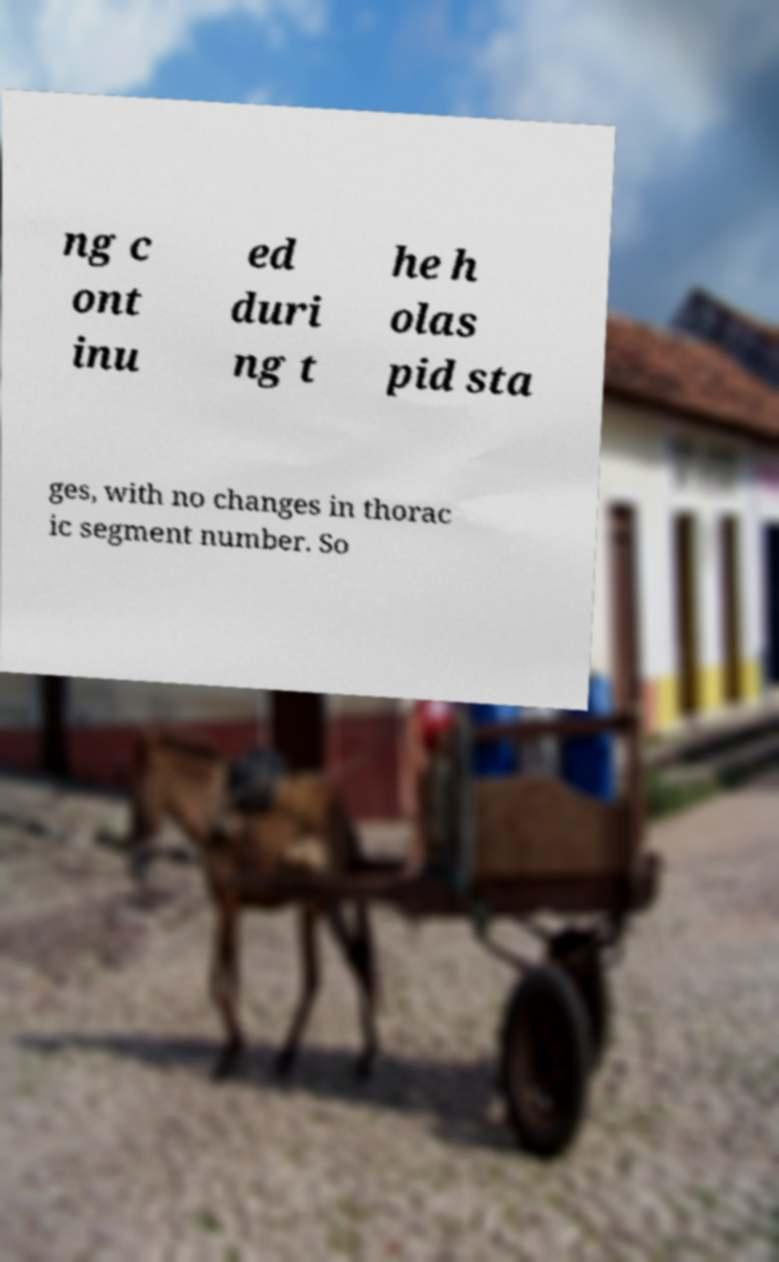Please identify and transcribe the text found in this image. ng c ont inu ed duri ng t he h olas pid sta ges, with no changes in thorac ic segment number. So 